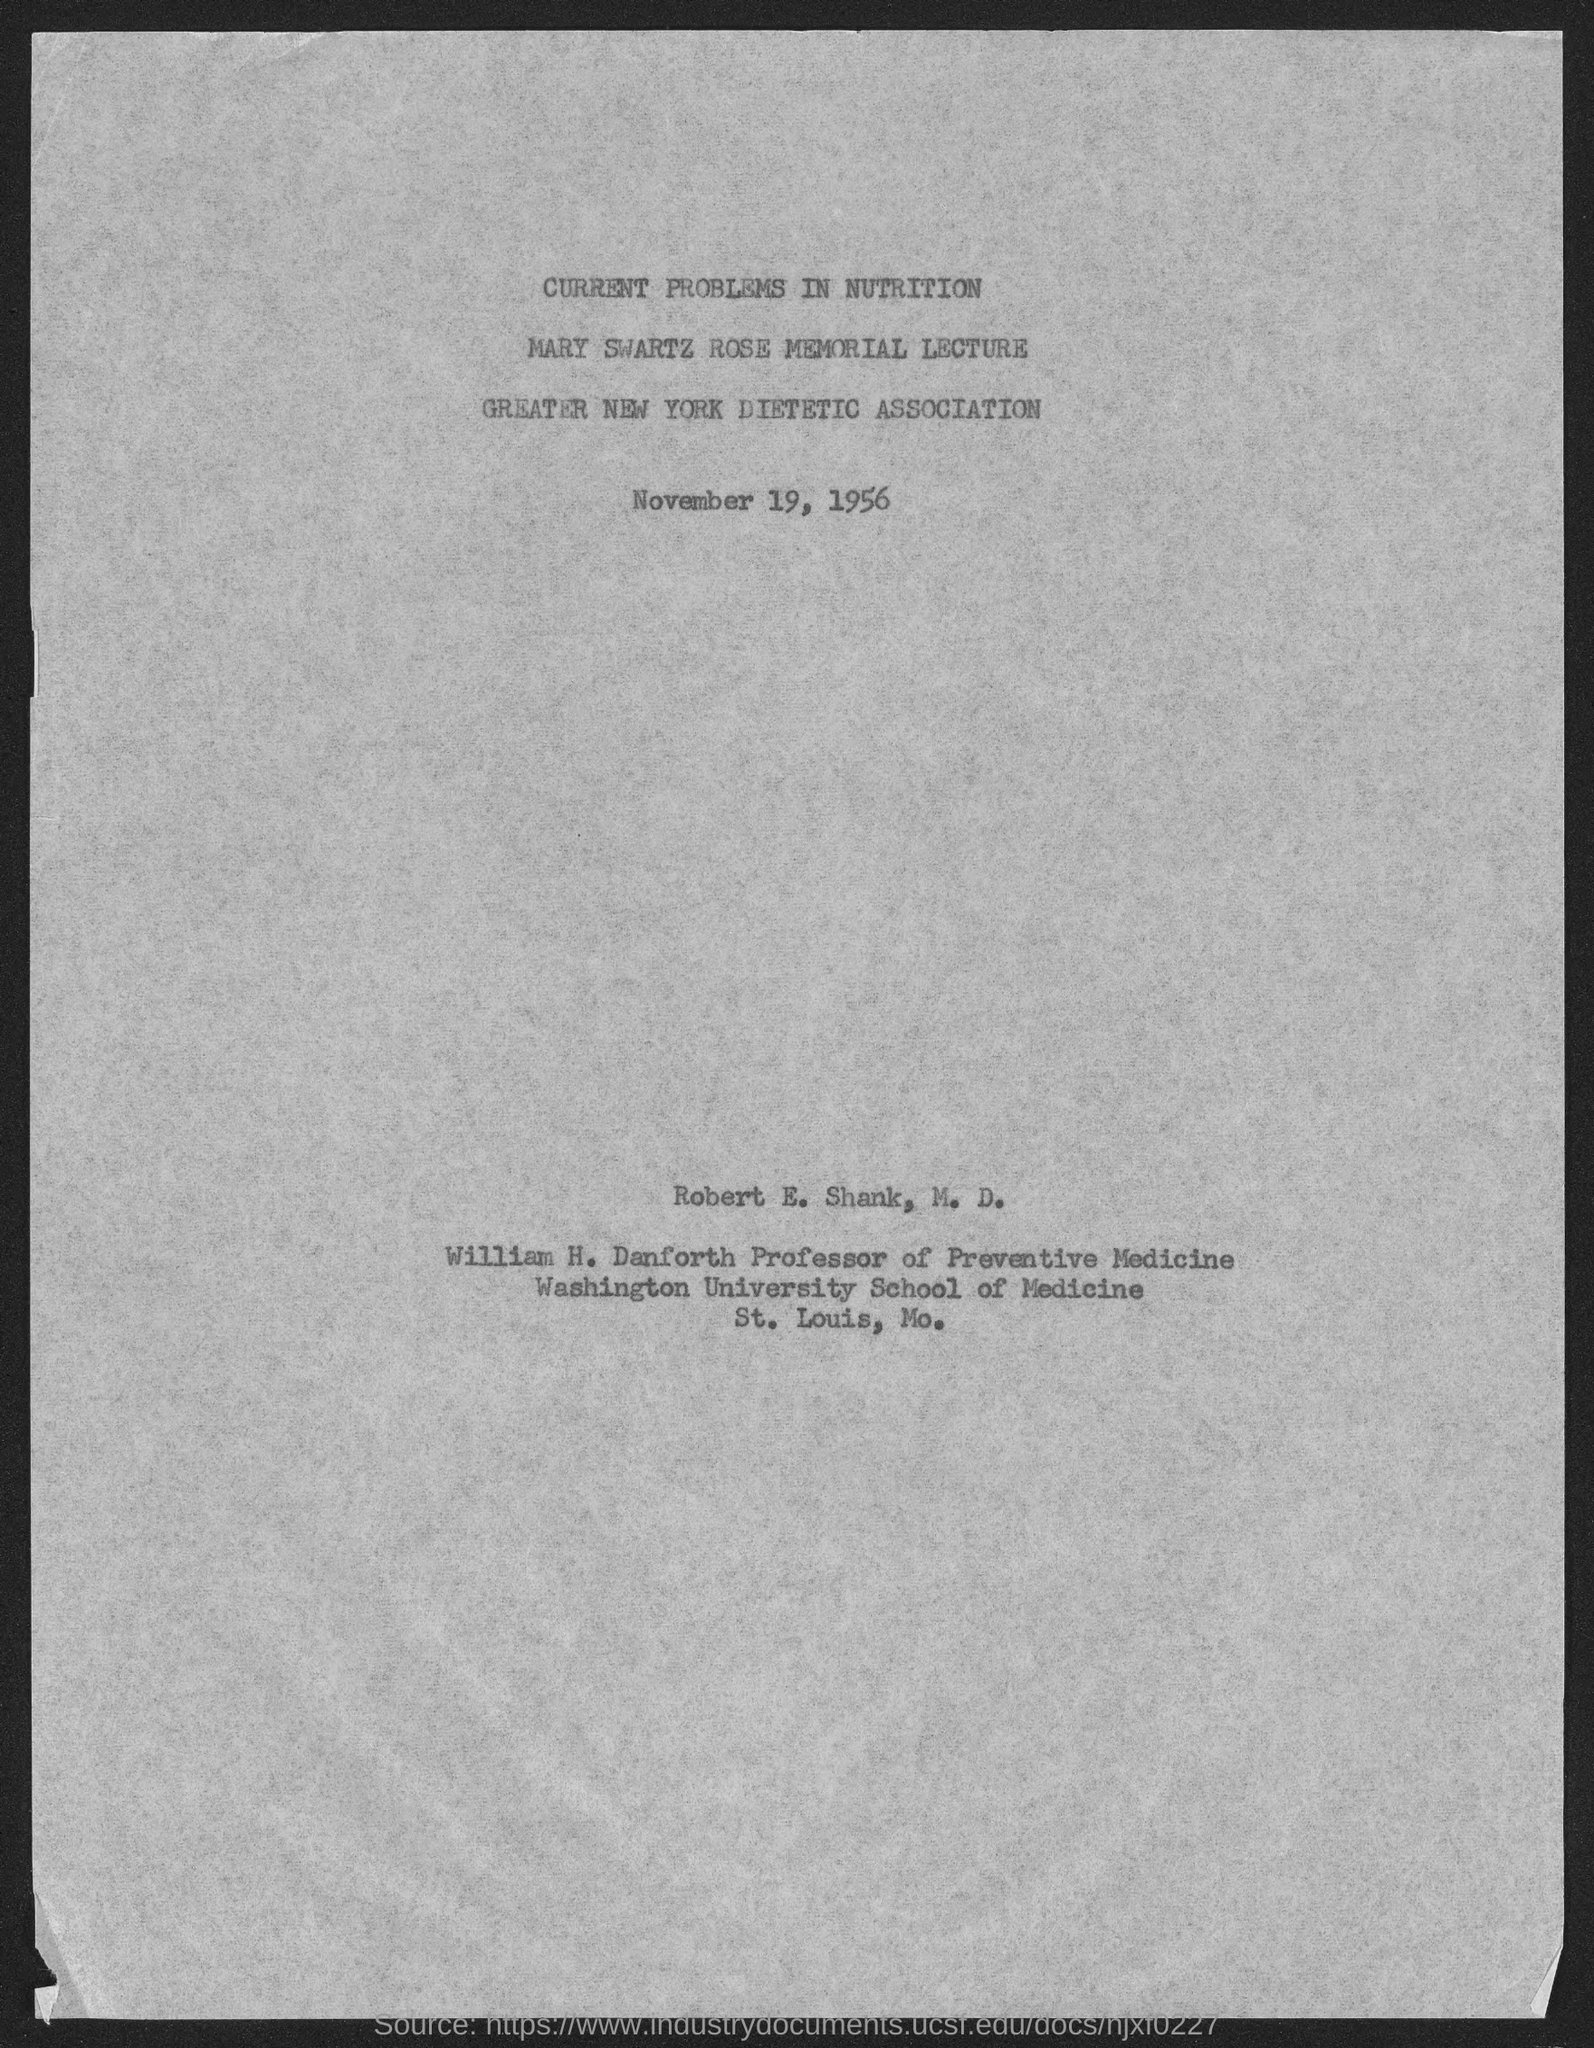List a handful of essential elements in this visual. William H. Danforth is the Professor of Preventive Medicine. The Mary Swartz Rose Memorial Lecture on "Current Problems in Nutrition" was held on November 19, 1956. 